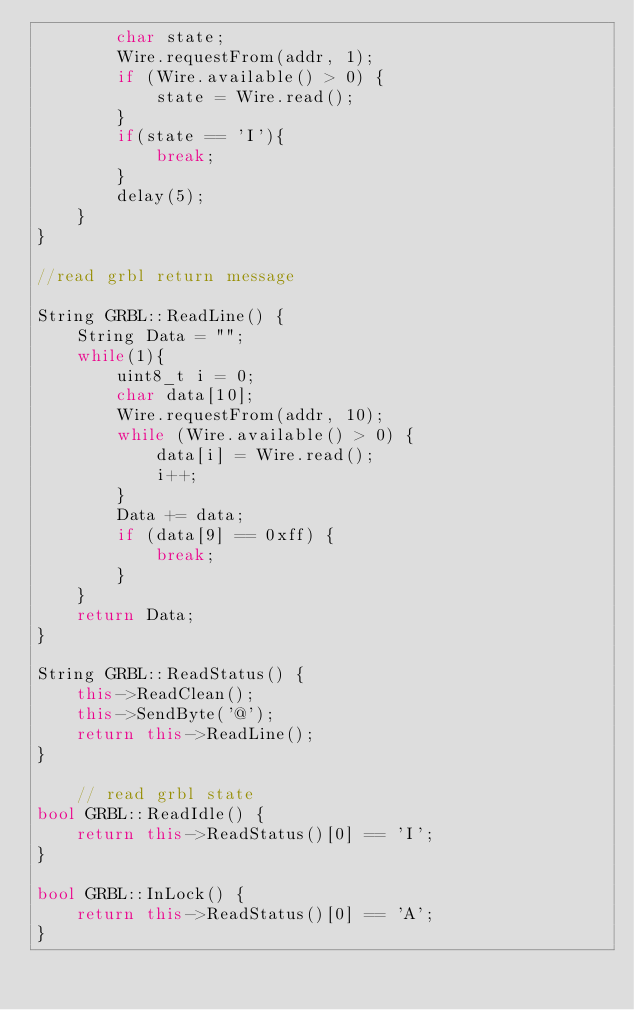<code> <loc_0><loc_0><loc_500><loc_500><_C++_>        char state;
        Wire.requestFrom(addr, 1);
        if (Wire.available() > 0) {
            state = Wire.read();
        }
        if(state == 'I'){
            break;
        }
        delay(5);
    }
}

//read grbl return message

String GRBL::ReadLine() {
    String Data = ""; 
    while(1){
        uint8_t i = 0;
        char data[10];
        Wire.requestFrom(addr, 10);
        while (Wire.available() > 0) {
            data[i] = Wire.read();
            i++;
        }
        Data += data;
        if (data[9] == 0xff) {
            break;
        }
    }
    return Data;
}

String GRBL::ReadStatus() {
    this->ReadClean();
    this->SendByte('@');
    return this->ReadLine();
}

    // read grbl state
bool GRBL::ReadIdle() {
    return this->ReadStatus()[0] == 'I';
}

bool GRBL::InLock() {
    return this->ReadStatus()[0] == 'A';
}</code> 